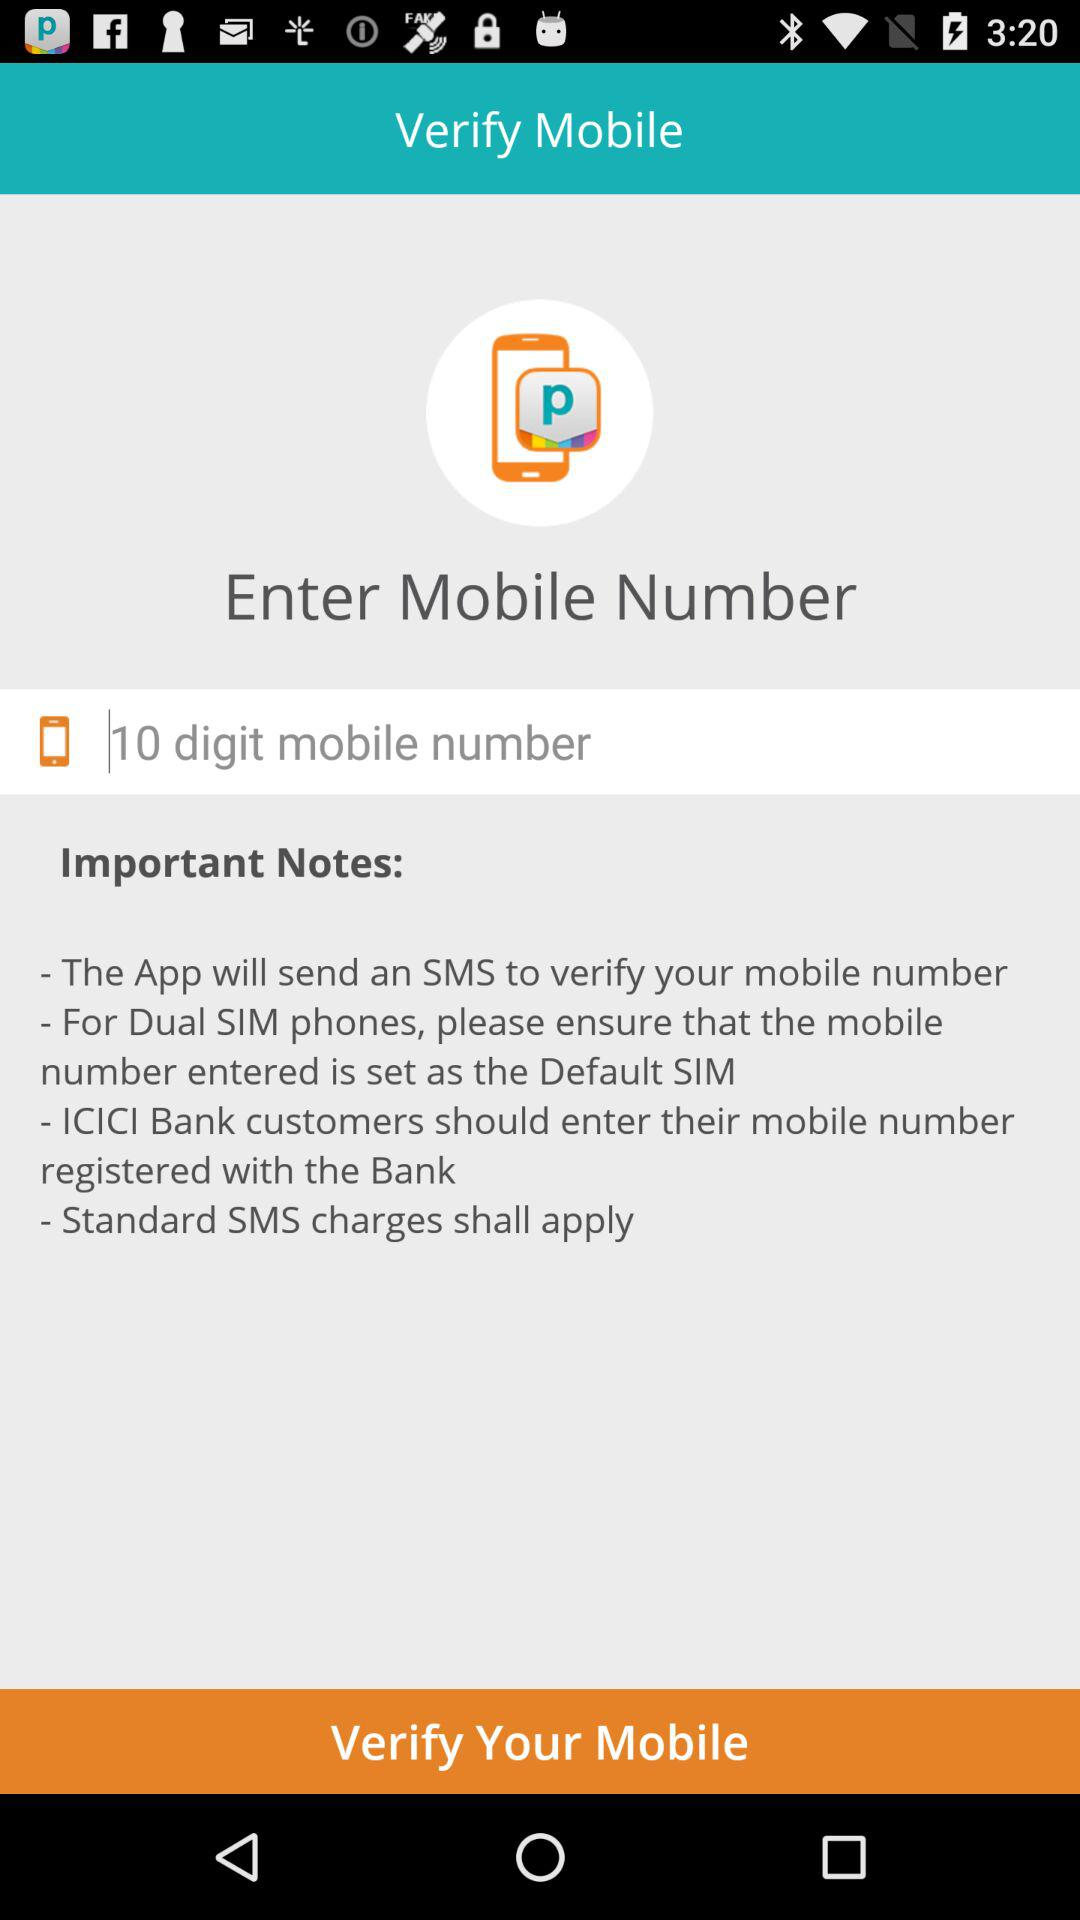How many digit's mobile number is required for verification? For verification, a 10-digit mobile number is required. 